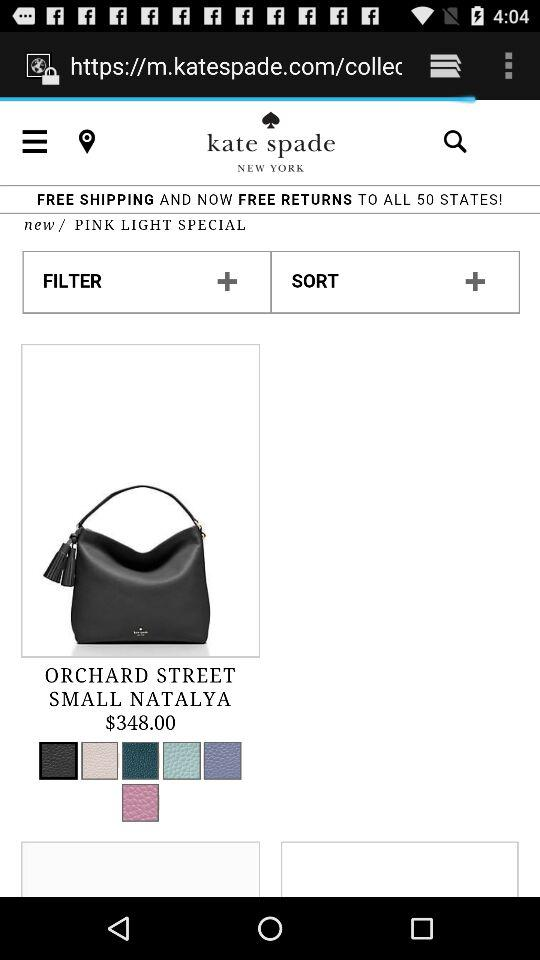What is the price of the "Orchard Street Small Natalya"? The price is $348. 